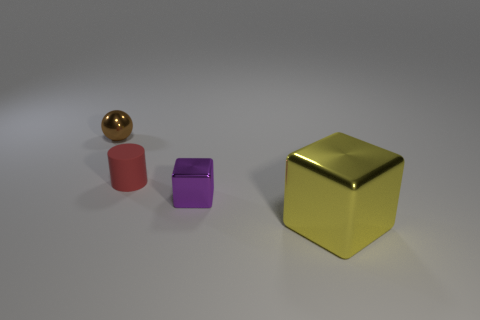Are there any other things that have the same size as the yellow metallic cube?
Your answer should be compact. No. Are there any other things that are the same material as the red object?
Provide a short and direct response. No. There is a object right of the purple shiny block; what is its material?
Keep it short and to the point. Metal. How many other objects are the same shape as the purple object?
Make the answer very short. 1. There is a thing that is to the right of the small metal object that is right of the brown metal thing; what is its material?
Offer a terse response. Metal. Are there any other red blocks made of the same material as the large block?
Offer a terse response. No. What is the shape of the large metallic thing?
Offer a very short reply. Cube. How many tiny green metal blocks are there?
Provide a succinct answer. 0. What color is the small metallic object behind the shiny cube behind the big yellow shiny object?
Ensure brevity in your answer.  Brown. What is the color of the sphere that is the same size as the rubber cylinder?
Your answer should be very brief. Brown. 